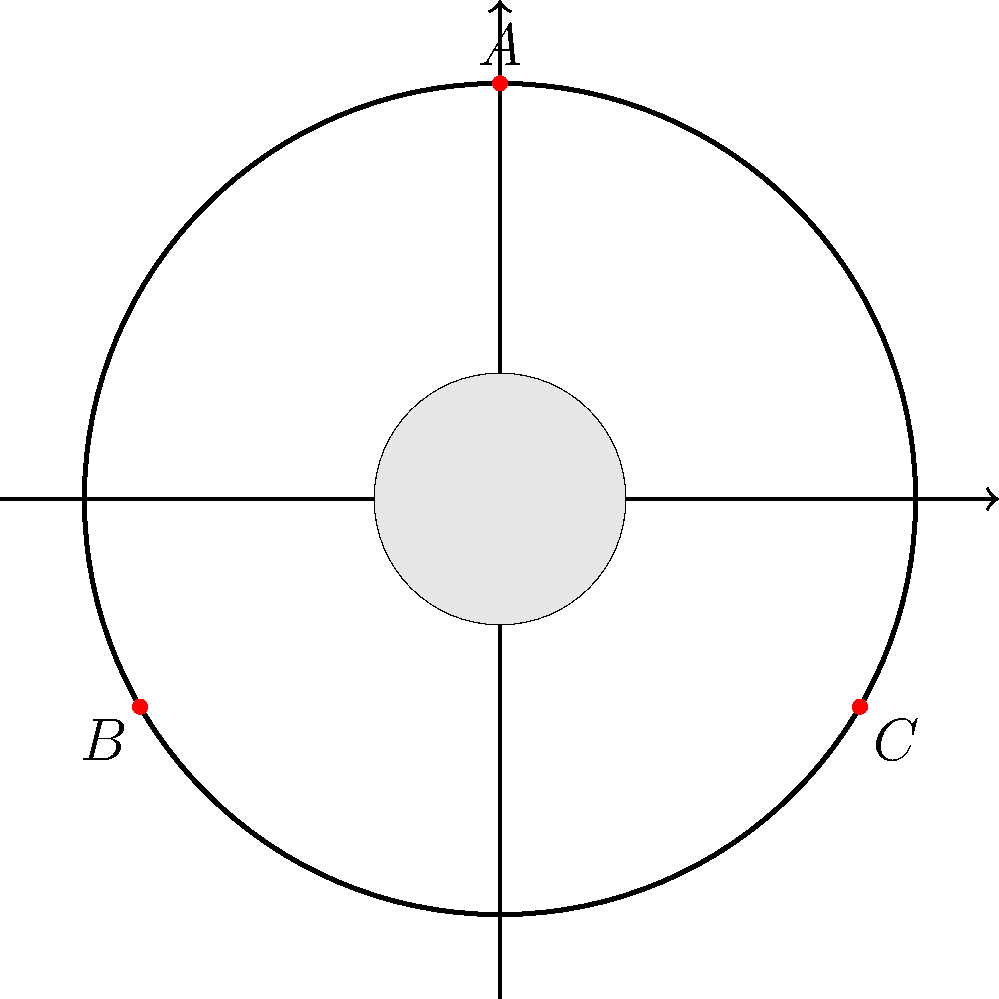Consider the symmetry group of a traditional Russian samovar, which can be approximated by a cylindrical shape with three equally spaced decorative elements around its circumference, as shown in the diagram. What is the order of this symmetry group? To determine the order of the symmetry group, we need to consider all possible symmetry operations that leave the samovar unchanged:

1. Rotational symmetry:
   - There are three 120° rotations (including the identity rotation of 0°)

2. Reflection symmetry:
   - There are three vertical reflection planes, each passing through one of the decorative elements and the center axis

Therefore, we can count the symmetry operations:
- 3 rotations (0°, 120°, 240°)
- 3 reflections

The total number of symmetry operations is 3 + 3 = 6.

In group theory, the order of a group is the number of elements in the group. Each symmetry operation corresponds to a group element.

Thus, the order of the symmetry group of the samovar is 6.

This group is isomorphic to the dihedral group $D_3$, which is the symmetry group of an equilateral triangle.
Answer: 6 